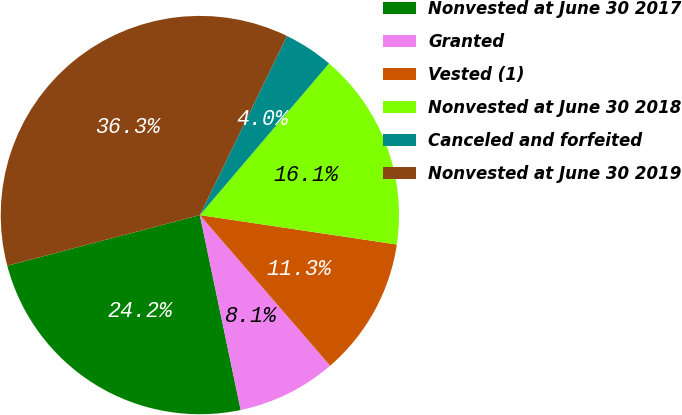Convert chart to OTSL. <chart><loc_0><loc_0><loc_500><loc_500><pie_chart><fcel>Nonvested at June 30 2017<fcel>Granted<fcel>Vested (1)<fcel>Nonvested at June 30 2018<fcel>Canceled and forfeited<fcel>Nonvested at June 30 2019<nl><fcel>24.19%<fcel>8.06%<fcel>11.29%<fcel>16.13%<fcel>4.03%<fcel>36.29%<nl></chart> 